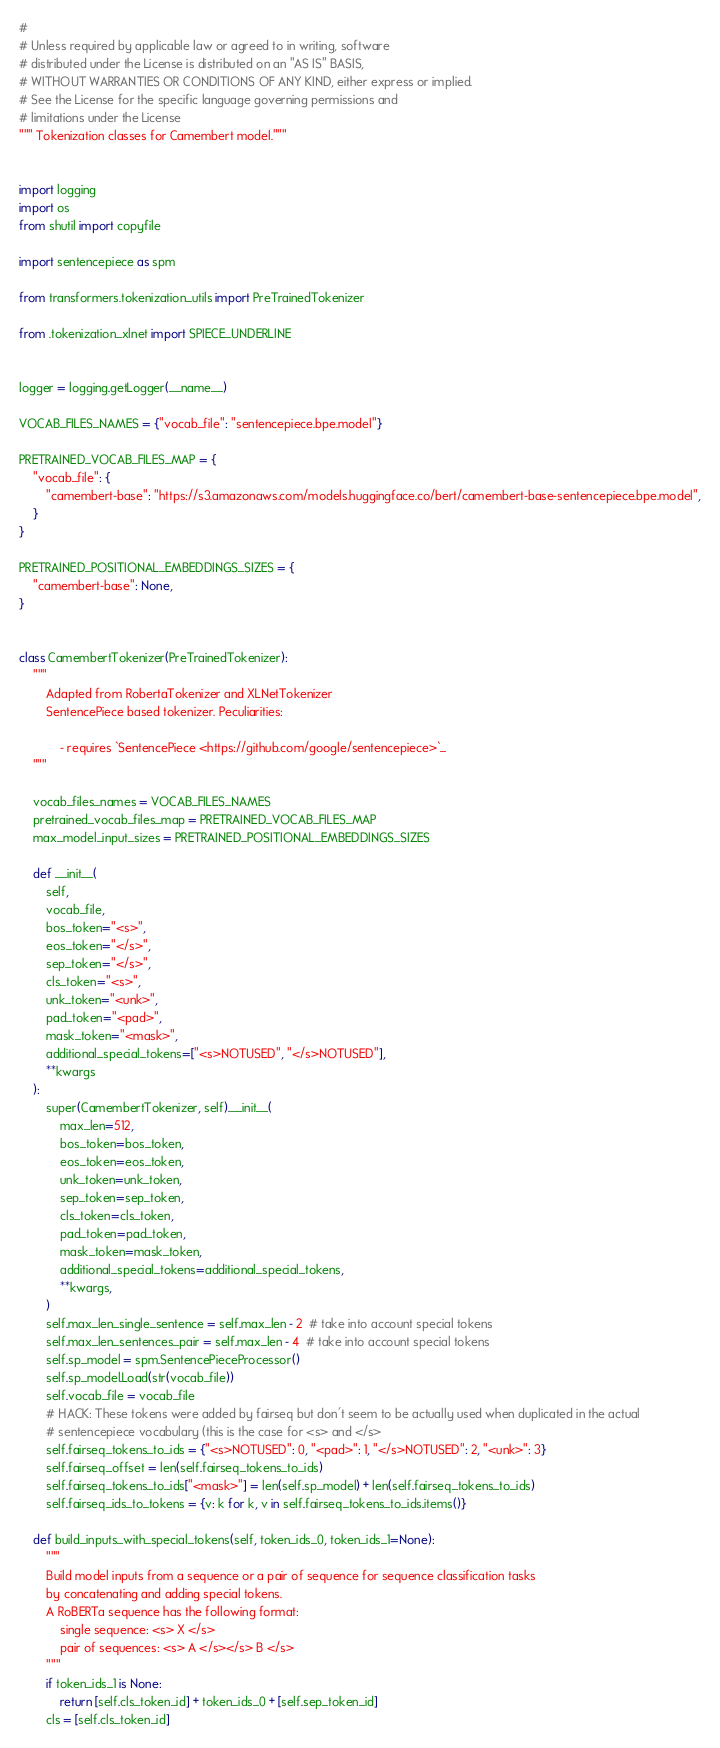Convert code to text. <code><loc_0><loc_0><loc_500><loc_500><_Python_>#
# Unless required by applicable law or agreed to in writing, software
# distributed under the License is distributed on an "AS IS" BASIS,
# WITHOUT WARRANTIES OR CONDITIONS OF ANY KIND, either express or implied.
# See the License for the specific language governing permissions and
# limitations under the License
""" Tokenization classes for Camembert model."""


import logging
import os
from shutil import copyfile

import sentencepiece as spm

from transformers.tokenization_utils import PreTrainedTokenizer

from .tokenization_xlnet import SPIECE_UNDERLINE


logger = logging.getLogger(__name__)

VOCAB_FILES_NAMES = {"vocab_file": "sentencepiece.bpe.model"}

PRETRAINED_VOCAB_FILES_MAP = {
    "vocab_file": {
        "camembert-base": "https://s3.amazonaws.com/models.huggingface.co/bert/camembert-base-sentencepiece.bpe.model",
    }
}

PRETRAINED_POSITIONAL_EMBEDDINGS_SIZES = {
    "camembert-base": None,
}


class CamembertTokenizer(PreTrainedTokenizer):
    """
        Adapted from RobertaTokenizer and XLNetTokenizer
        SentencePiece based tokenizer. Peculiarities:

            - requires `SentencePiece <https://github.com/google/sentencepiece>`_
    """

    vocab_files_names = VOCAB_FILES_NAMES
    pretrained_vocab_files_map = PRETRAINED_VOCAB_FILES_MAP
    max_model_input_sizes = PRETRAINED_POSITIONAL_EMBEDDINGS_SIZES

    def __init__(
        self,
        vocab_file,
        bos_token="<s>",
        eos_token="</s>",
        sep_token="</s>",
        cls_token="<s>",
        unk_token="<unk>",
        pad_token="<pad>",
        mask_token="<mask>",
        additional_special_tokens=["<s>NOTUSED", "</s>NOTUSED"],
        **kwargs
    ):
        super(CamembertTokenizer, self).__init__(
            max_len=512,
            bos_token=bos_token,
            eos_token=eos_token,
            unk_token=unk_token,
            sep_token=sep_token,
            cls_token=cls_token,
            pad_token=pad_token,
            mask_token=mask_token,
            additional_special_tokens=additional_special_tokens,
            **kwargs,
        )
        self.max_len_single_sentence = self.max_len - 2  # take into account special tokens
        self.max_len_sentences_pair = self.max_len - 4  # take into account special tokens
        self.sp_model = spm.SentencePieceProcessor()
        self.sp_model.Load(str(vocab_file))
        self.vocab_file = vocab_file
        # HACK: These tokens were added by fairseq but don't seem to be actually used when duplicated in the actual
        # sentencepiece vocabulary (this is the case for <s> and </s>
        self.fairseq_tokens_to_ids = {"<s>NOTUSED": 0, "<pad>": 1, "</s>NOTUSED": 2, "<unk>": 3}
        self.fairseq_offset = len(self.fairseq_tokens_to_ids)
        self.fairseq_tokens_to_ids["<mask>"] = len(self.sp_model) + len(self.fairseq_tokens_to_ids)
        self.fairseq_ids_to_tokens = {v: k for k, v in self.fairseq_tokens_to_ids.items()}

    def build_inputs_with_special_tokens(self, token_ids_0, token_ids_1=None):
        """
        Build model inputs from a sequence or a pair of sequence for sequence classification tasks
        by concatenating and adding special tokens.
        A RoBERTa sequence has the following format:
            single sequence: <s> X </s>
            pair of sequences: <s> A </s></s> B </s>
        """
        if token_ids_1 is None:
            return [self.cls_token_id] + token_ids_0 + [self.sep_token_id]
        cls = [self.cls_token_id]</code> 